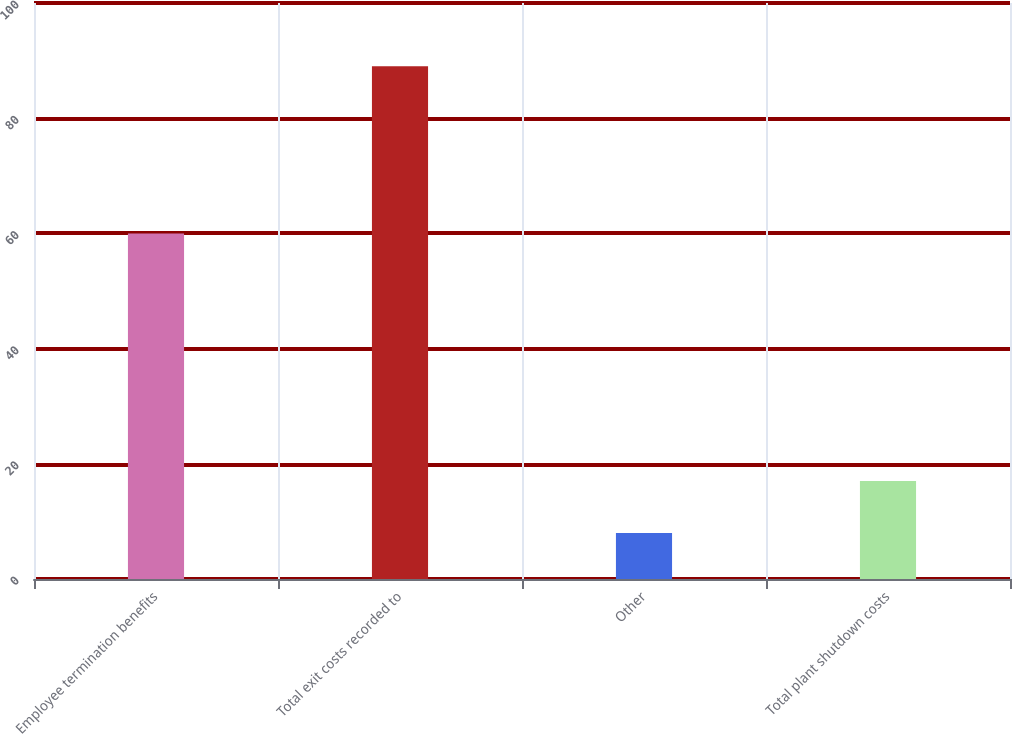Convert chart. <chart><loc_0><loc_0><loc_500><loc_500><bar_chart><fcel>Employee termination benefits<fcel>Total exit costs recorded to<fcel>Other<fcel>Total plant shutdown costs<nl><fcel>60<fcel>89<fcel>8<fcel>17<nl></chart> 